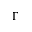Convert formula to latex. <formula><loc_0><loc_0><loc_500><loc_500>\Gamma</formula> 